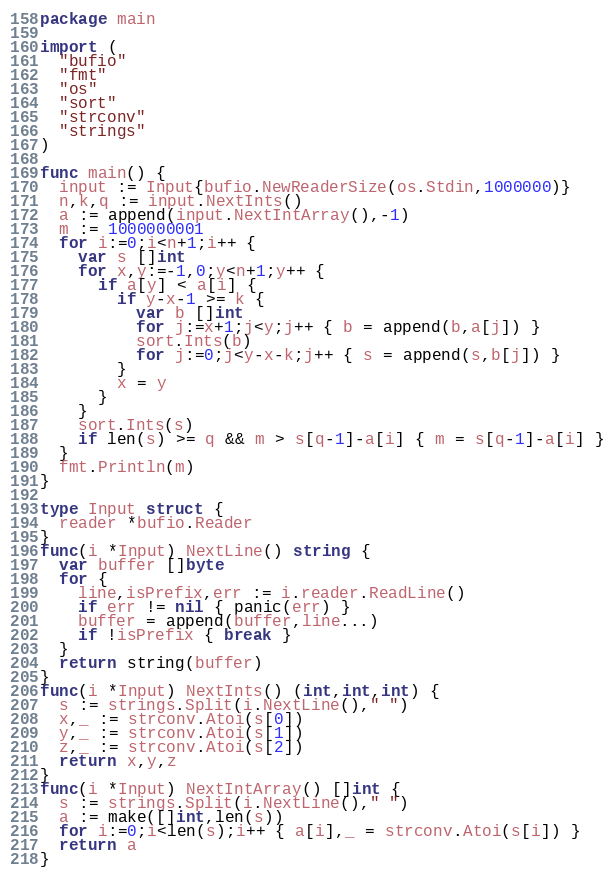<code> <loc_0><loc_0><loc_500><loc_500><_Go_>package main

import (
  "bufio"
  "fmt"
  "os"
  "sort"
  "strconv"
  "strings"
)

func main() {
  input := Input{bufio.NewReaderSize(os.Stdin,1000000)}
  n,k,q := input.NextInts()
  a := append(input.NextIntArray(),-1)
  m := 1000000001
  for i:=0;i<n+1;i++ {
    var s []int
    for x,y:=-1,0;y<n+1;y++ {
      if a[y] < a[i] {
        if y-x-1 >= k {
          var b []int
          for j:=x+1;j<y;j++ { b = append(b,a[j]) }
          sort.Ints(b)
          for j:=0;j<y-x-k;j++ { s = append(s,b[j]) }
        }
        x = y
      }
    }
    sort.Ints(s)
    if len(s) >= q && m > s[q-1]-a[i] { m = s[q-1]-a[i] }
  }
  fmt.Println(m)
}

type Input struct {
  reader *bufio.Reader
}
func(i *Input) NextLine() string {
  var buffer []byte
  for {
    line,isPrefix,err := i.reader.ReadLine()
    if err != nil { panic(err) }
    buffer = append(buffer,line...)
    if !isPrefix { break }
  }
  return string(buffer)
}
func(i *Input) NextInts() (int,int,int) {
  s := strings.Split(i.NextLine()," ")
  x,_ := strconv.Atoi(s[0])
  y,_ := strconv.Atoi(s[1])
  z,_ := strconv.Atoi(s[2])
  return x,y,z
}
func(i *Input) NextIntArray() []int {
  s := strings.Split(i.NextLine()," ")
  a := make([]int,len(s))
  for i:=0;i<len(s);i++ { a[i],_ = strconv.Atoi(s[i]) }
  return a
}</code> 